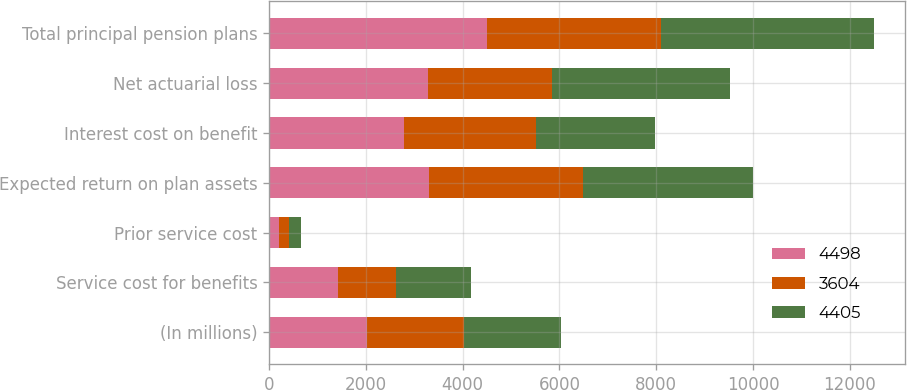Convert chart to OTSL. <chart><loc_0><loc_0><loc_500><loc_500><stacked_bar_chart><ecel><fcel>(In millions)<fcel>Service cost for benefits<fcel>Prior service cost<fcel>Expected return on plan assets<fcel>Interest cost on benefit<fcel>Net actuarial loss<fcel>Total principal pension plans<nl><fcel>4498<fcel>2015<fcel>1424<fcel>205<fcel>3302<fcel>2778<fcel>3288<fcel>4498<nl><fcel>3604<fcel>2014<fcel>1205<fcel>214<fcel>3190<fcel>2745<fcel>2565<fcel>3604<nl><fcel>4405<fcel>2013<fcel>1535<fcel>246<fcel>3500<fcel>2460<fcel>3664<fcel>4405<nl></chart> 